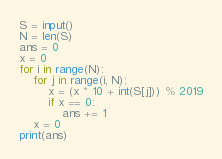Convert code to text. <code><loc_0><loc_0><loc_500><loc_500><_Python_>S = input()
N = len(S)
ans = 0
x = 0
for i in range(N):
	for j in range(i, N):
		x = (x * 10 + int(S[j])) % 2019
		if x == 0:
			ans += 1
	x = 0
print(ans)</code> 